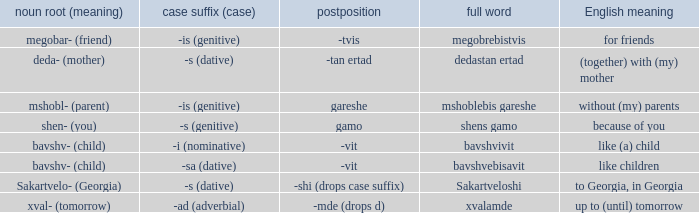What is the postposition, when the noun base (meaning) is "mshobl- (parent)"? Gareshe. 